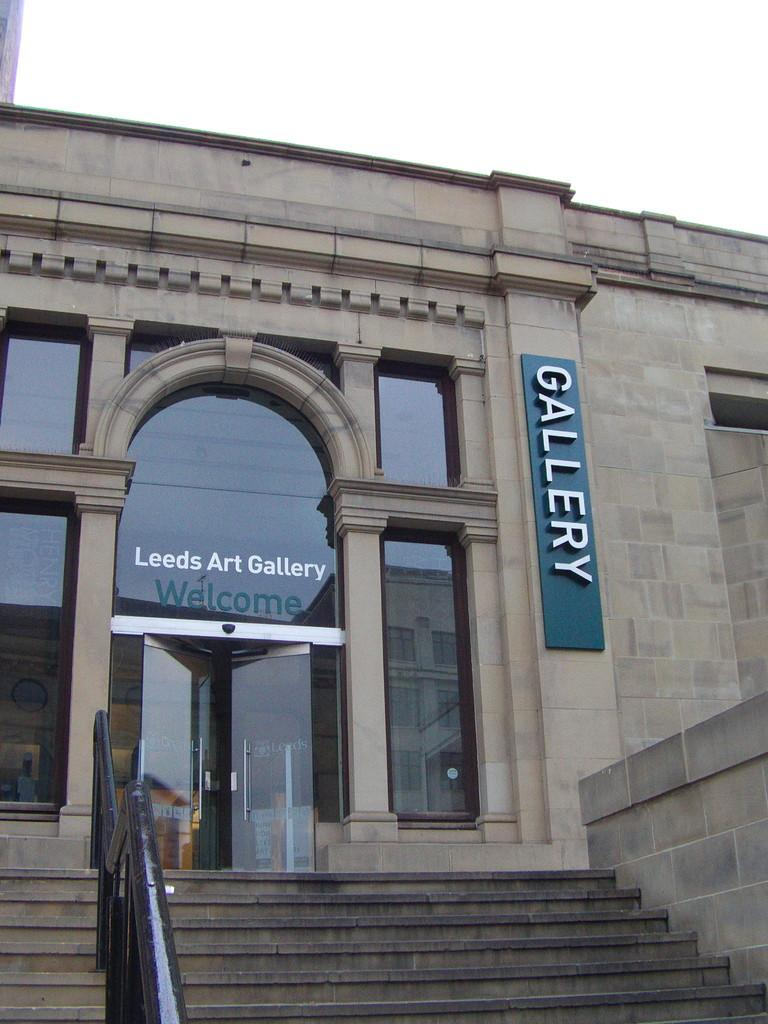What type of structure is present in the image? There are stairs in the image. What feature do the stairs have? The stairs have a railing. What color is the building in the image? The building in the image is brown-colored. What type of doors can be seen in the image? There are glass doors in the image. What is the color of the board in the image? The board in the image is blue-colored. What can be seen in the background of the image? The sky is visible in the background of the image. Can you tell me how many wings the writer has in the image? There is no writer or wings present in the image. 